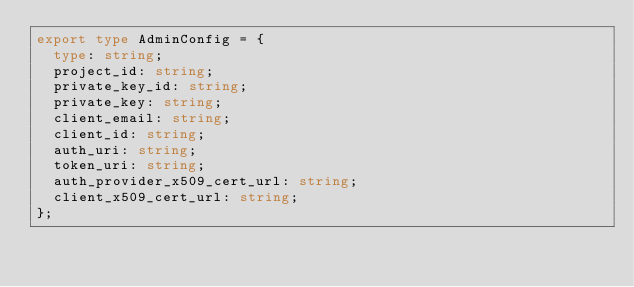Convert code to text. <code><loc_0><loc_0><loc_500><loc_500><_TypeScript_>export type AdminConfig = {
  type: string;
  project_id: string;
  private_key_id: string;
  private_key: string;
  client_email: string;
  client_id: string;
  auth_uri: string;
  token_uri: string;
  auth_provider_x509_cert_url: string;
  client_x509_cert_url: string;
};
</code> 